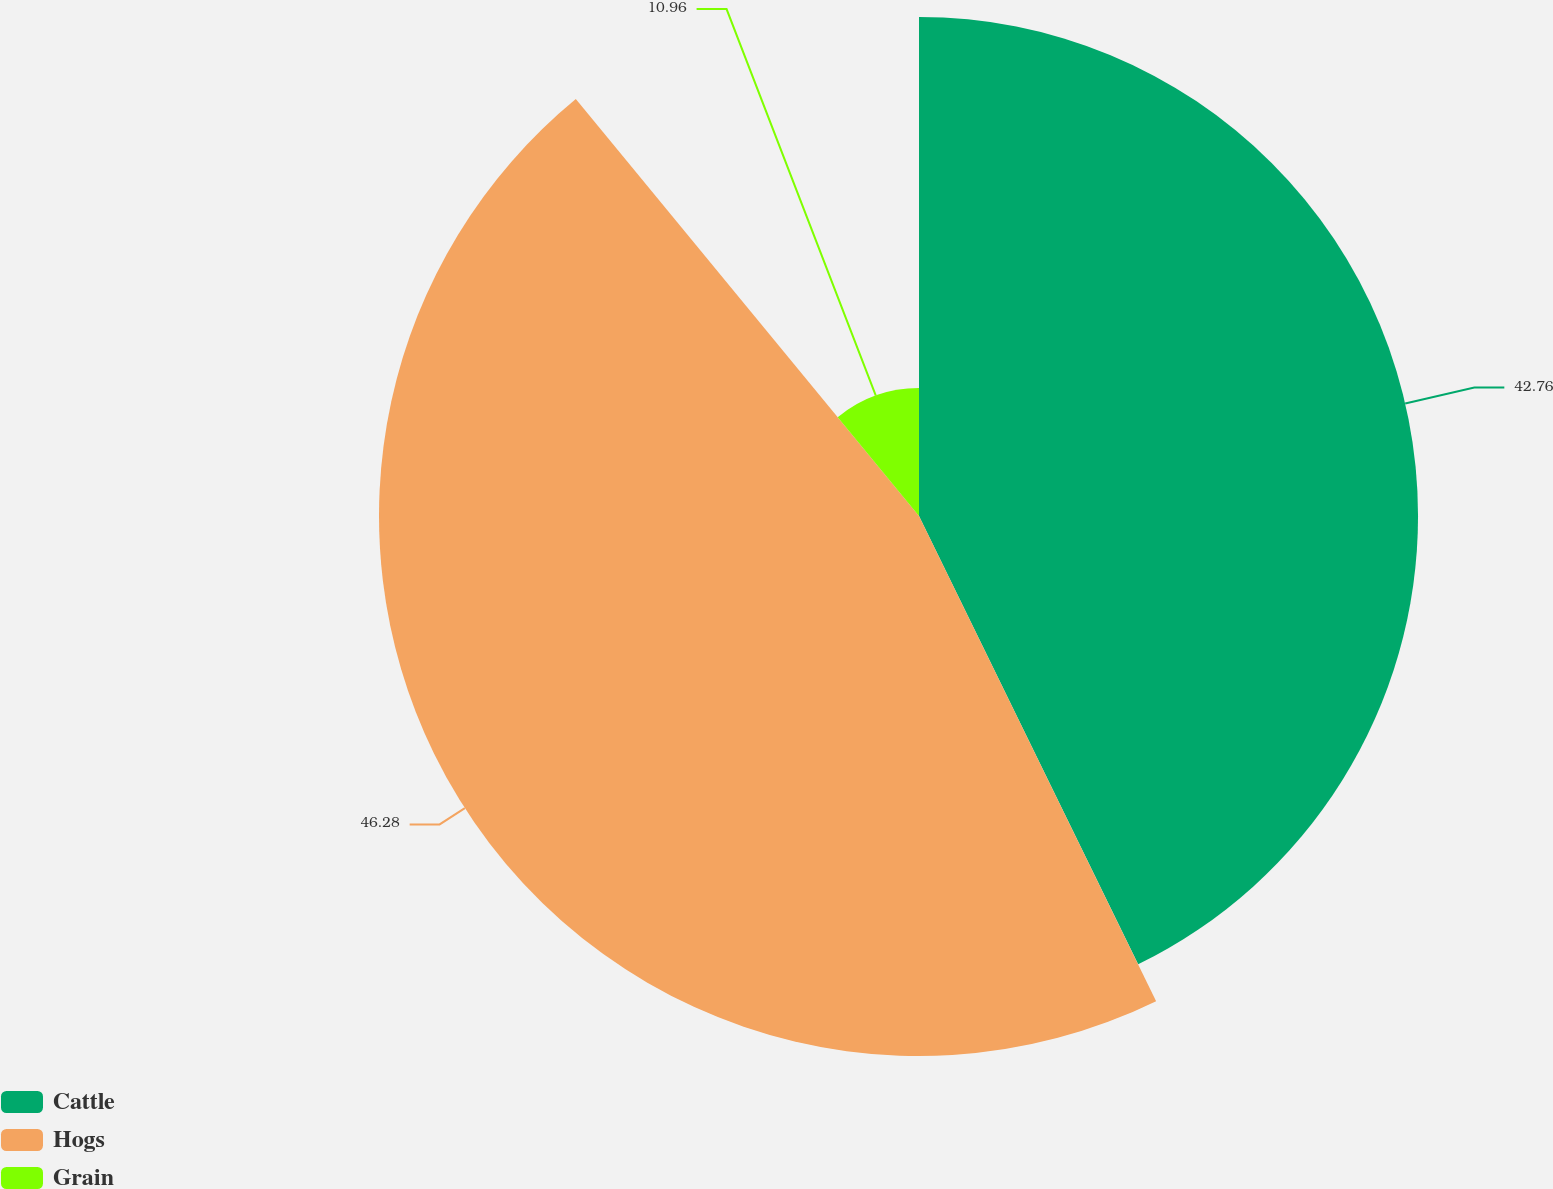<chart> <loc_0><loc_0><loc_500><loc_500><pie_chart><fcel>Cattle<fcel>Hogs<fcel>Grain<nl><fcel>42.76%<fcel>46.27%<fcel>10.96%<nl></chart> 